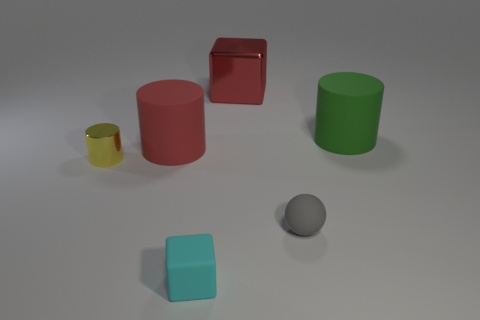Add 3 cyan rubber blocks. How many objects exist? 9 Subtract all balls. How many objects are left? 5 Subtract all large cyan metallic things. Subtract all red matte things. How many objects are left? 5 Add 3 balls. How many balls are left? 4 Add 2 large objects. How many large objects exist? 5 Subtract 0 purple balls. How many objects are left? 6 